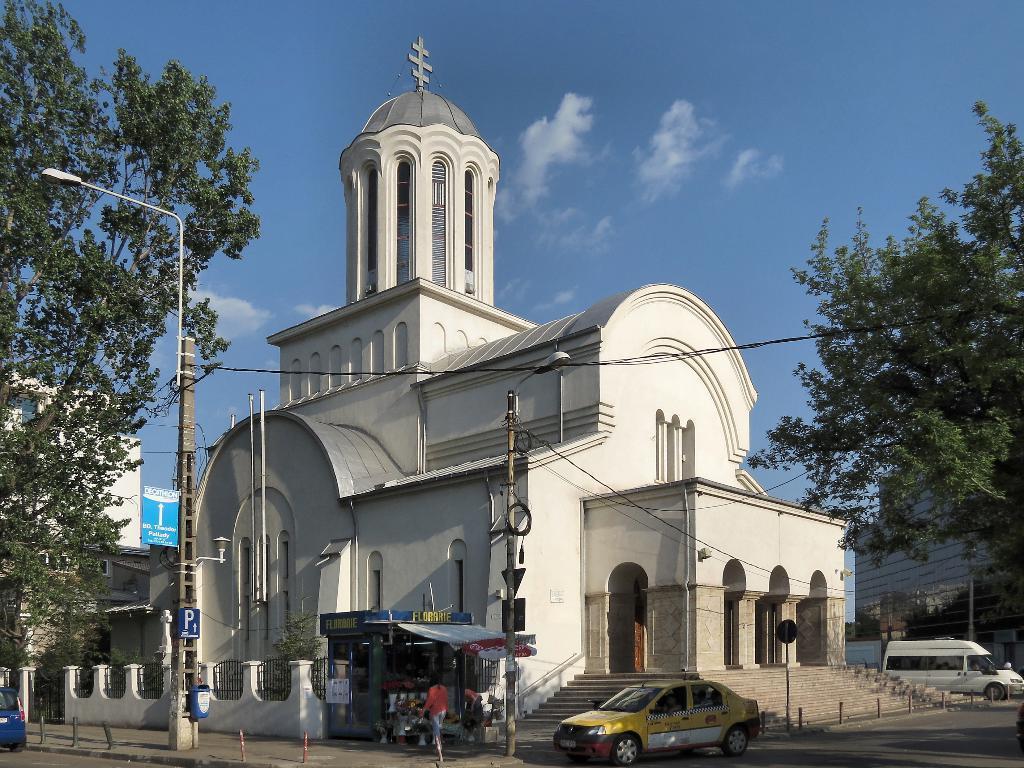Describe this image in one or two sentences. In this image we can see parish building of white color there are some trees, street lights and some vehicles moving on the road there is shop in front of parish and in background of the image there is clear sky. 